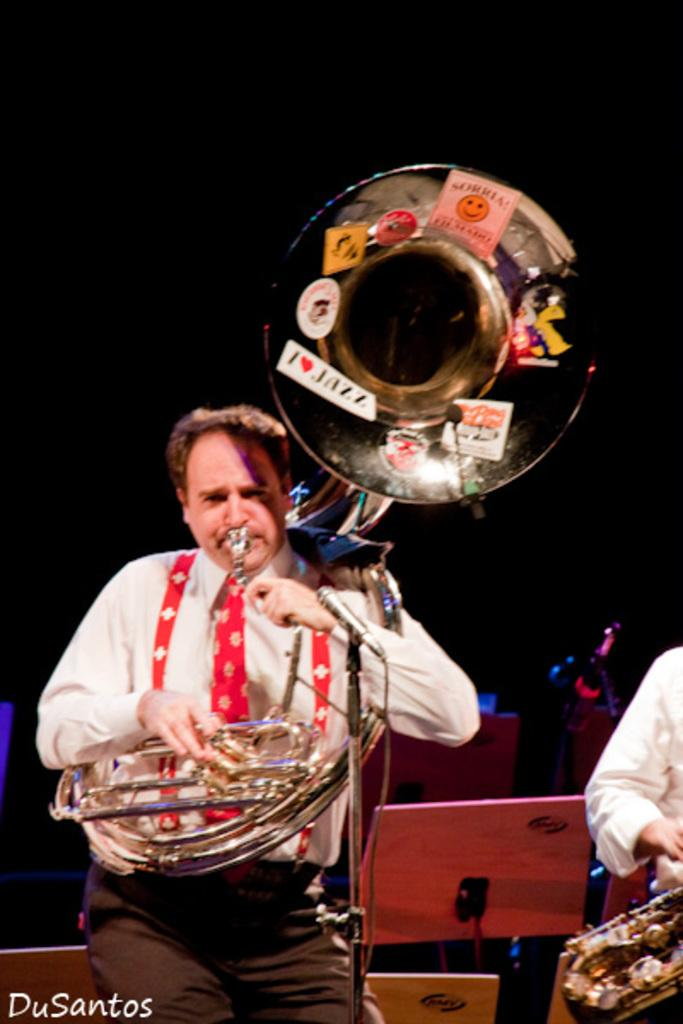What object in the image is associated with creating sound? There is a musical instrument in the image. How many people are visible in the image? Two people are present in the image. What color are the shirts worn by the people in the image? Both people are wearing white color shirts. What can be said about the lighting conditions in the image? The background of the image is dark. What type of railway is visible in the image? There is no railway present in the image. What genre of music is being played by the musical instrument in the image? The image does not provide enough information to determine the genre of music being played by the musical instrument. 